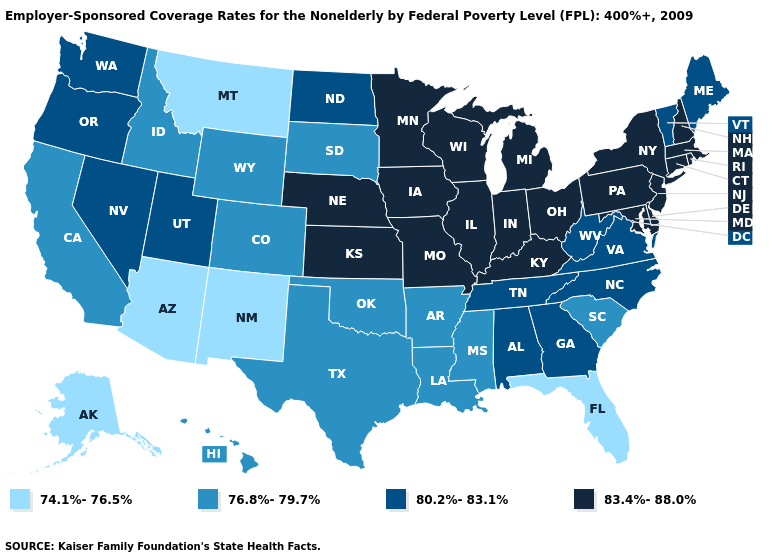Does the first symbol in the legend represent the smallest category?
Quick response, please. Yes. Which states hav the highest value in the West?
Answer briefly. Nevada, Oregon, Utah, Washington. Among the states that border Montana , which have the lowest value?
Keep it brief. Idaho, South Dakota, Wyoming. What is the value of Connecticut?
Give a very brief answer. 83.4%-88.0%. What is the lowest value in states that border Arkansas?
Answer briefly. 76.8%-79.7%. Which states have the lowest value in the USA?
Short answer required. Alaska, Arizona, Florida, Montana, New Mexico. Name the states that have a value in the range 80.2%-83.1%?
Write a very short answer. Alabama, Georgia, Maine, Nevada, North Carolina, North Dakota, Oregon, Tennessee, Utah, Vermont, Virginia, Washington, West Virginia. Among the states that border New York , does New Jersey have the lowest value?
Write a very short answer. No. What is the value of New Mexico?
Give a very brief answer. 74.1%-76.5%. What is the lowest value in states that border Kentucky?
Keep it brief. 80.2%-83.1%. What is the lowest value in the West?
Quick response, please. 74.1%-76.5%. Does Maryland have the highest value in the USA?
Keep it brief. Yes. What is the highest value in states that border Alabama?
Be succinct. 80.2%-83.1%. Does the map have missing data?
Quick response, please. No. What is the highest value in the USA?
Quick response, please. 83.4%-88.0%. 